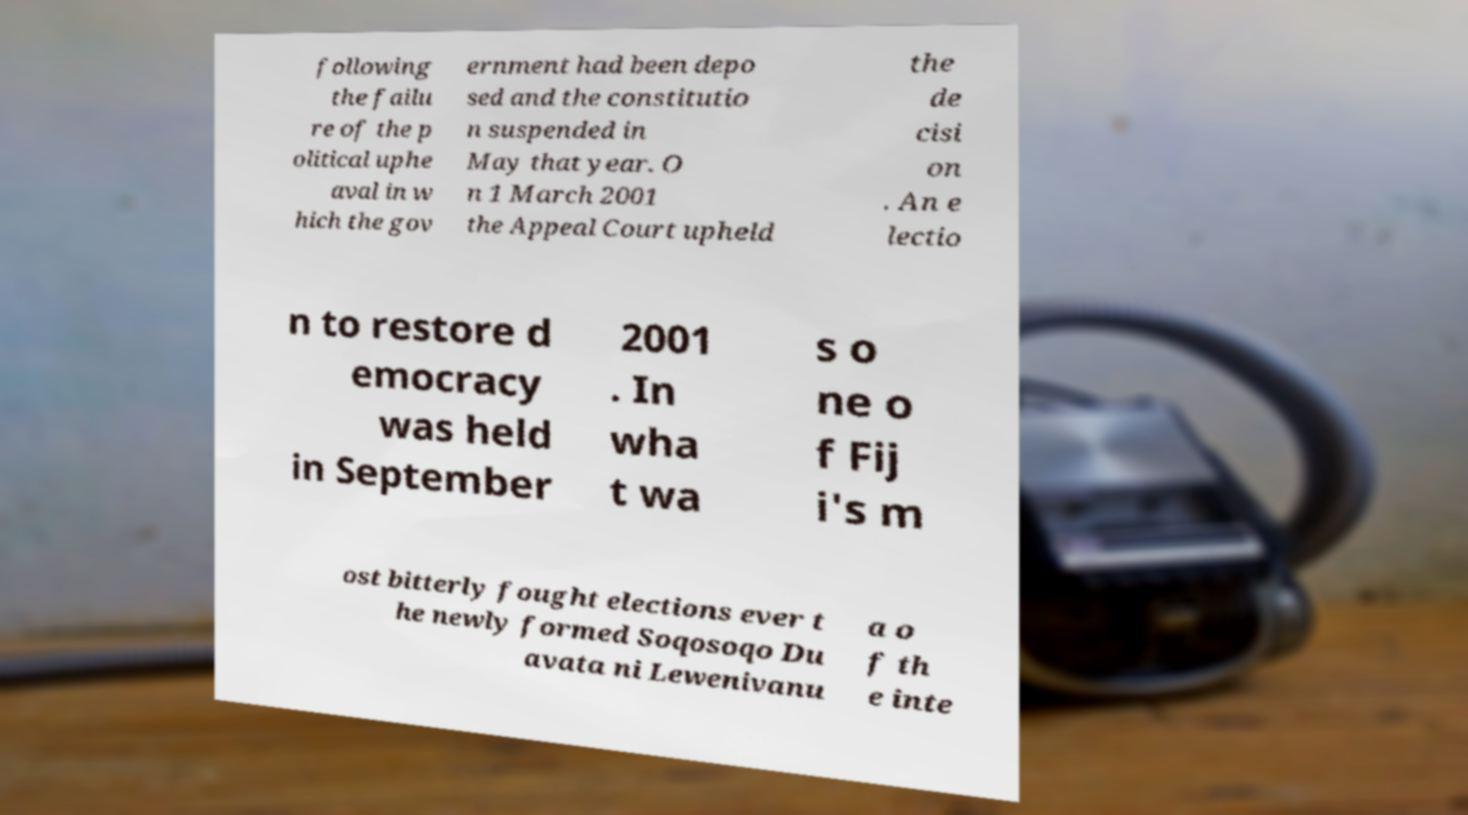Could you extract and type out the text from this image? following the failu re of the p olitical uphe aval in w hich the gov ernment had been depo sed and the constitutio n suspended in May that year. O n 1 March 2001 the Appeal Court upheld the de cisi on . An e lectio n to restore d emocracy was held in September 2001 . In wha t wa s o ne o f Fij i's m ost bitterly fought elections ever t he newly formed Soqosoqo Du avata ni Lewenivanu a o f th e inte 